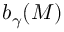Convert formula to latex. <formula><loc_0><loc_0><loc_500><loc_500>b _ { \gamma } ( M )</formula> 